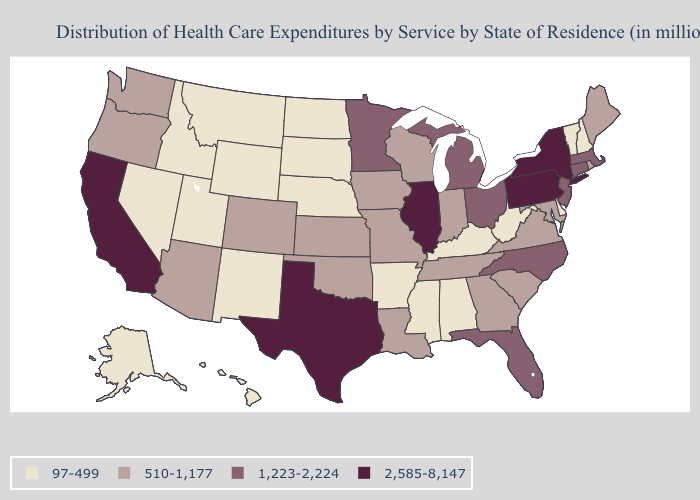What is the value of Mississippi?
Answer briefly. 97-499. What is the value of Nevada?
Give a very brief answer. 97-499. What is the highest value in states that border Nebraska?
Keep it brief. 510-1,177. Which states have the highest value in the USA?
Concise answer only. California, Illinois, New York, Pennsylvania, Texas. What is the value of South Dakota?
Write a very short answer. 97-499. Does Vermont have the same value as New Jersey?
Concise answer only. No. Among the states that border Oklahoma , which have the highest value?
Concise answer only. Texas. Among the states that border Washington , does Oregon have the lowest value?
Give a very brief answer. No. Which states have the lowest value in the Northeast?
Give a very brief answer. New Hampshire, Vermont. Among the states that border Ohio , which have the lowest value?
Short answer required. Kentucky, West Virginia. What is the highest value in the USA?
Write a very short answer. 2,585-8,147. Does Missouri have the highest value in the USA?
Concise answer only. No. Among the states that border North Dakota , which have the highest value?
Quick response, please. Minnesota. Does Wisconsin have a lower value than Minnesota?
Be succinct. Yes. 